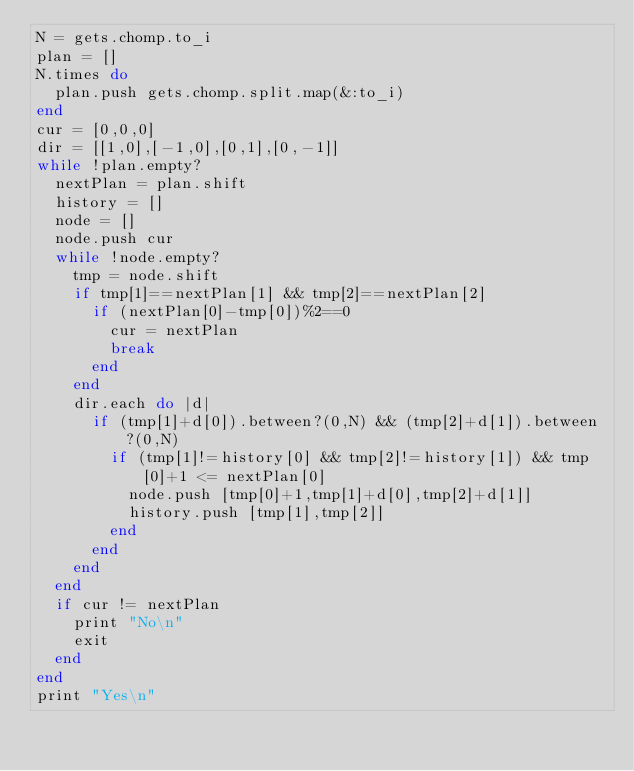<code> <loc_0><loc_0><loc_500><loc_500><_Ruby_>N = gets.chomp.to_i
plan = []
N.times do
  plan.push gets.chomp.split.map(&:to_i)
end
cur = [0,0,0]
dir = [[1,0],[-1,0],[0,1],[0,-1]]
while !plan.empty?
  nextPlan = plan.shift
  history = []
  node = []
  node.push cur
  while !node.empty?
    tmp = node.shift
    if tmp[1]==nextPlan[1] && tmp[2]==nextPlan[2]
      if (nextPlan[0]-tmp[0])%2==0
        cur = nextPlan
        break
      end
    end
    dir.each do |d|
      if (tmp[1]+d[0]).between?(0,N) && (tmp[2]+d[1]).between?(0,N)
        if (tmp[1]!=history[0] && tmp[2]!=history[1]) && tmp[0]+1 <= nextPlan[0]
          node.push [tmp[0]+1,tmp[1]+d[0],tmp[2]+d[1]]
          history.push [tmp[1],tmp[2]]
        end
      end
    end
  end
  if cur != nextPlan
    print "No\n"
    exit
  end
end
print "Yes\n"</code> 